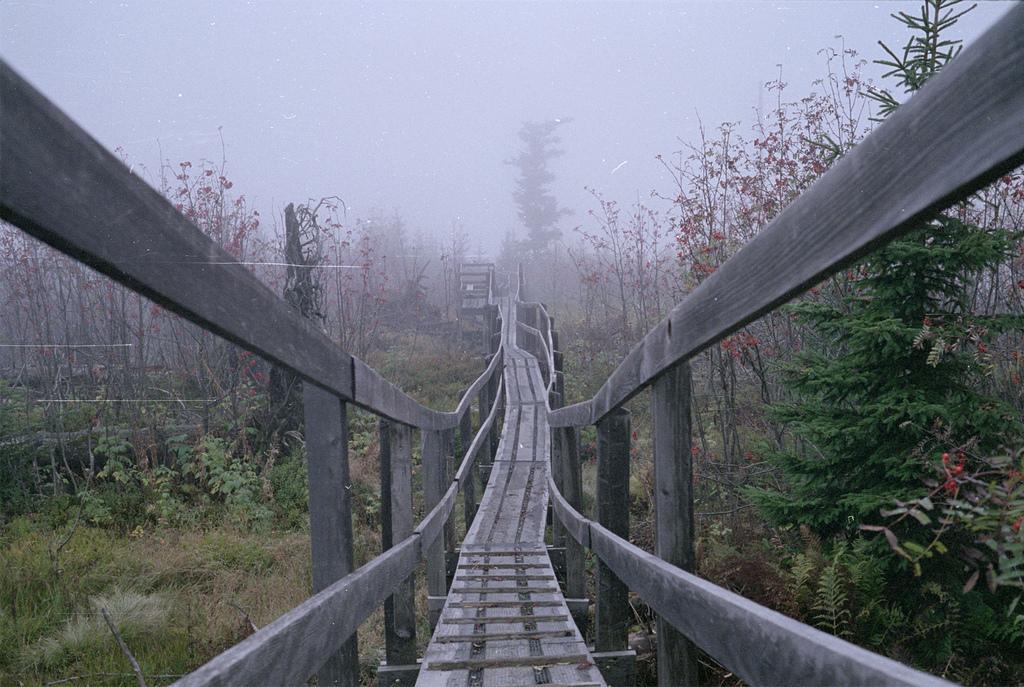Could you give a brief overview of what you see in this image? In this picture we can see a wooden bridge. This is grass and these are the trees. And on the background there is a sky. 